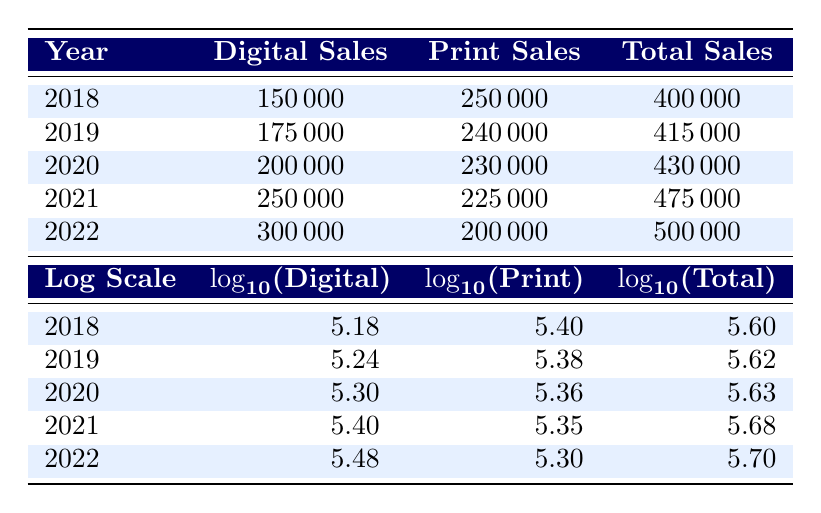What were the Digital Book Sales in 2021? The table shows that the Digital Book Sales in 2021 were 250,000.
Answer: 250,000 What was the total number of Print Book Sales in 2019? According to the table, the Print Book Sales in 2019 were 240,000.
Answer: 240,000 What is the difference between Total Book Sales in 2022 and 2021? In 2022 the Total Book Sales were 500,000 and in 2021 they were 475,000. The difference is calculated as 500,000 - 475,000 = 25,000.
Answer: 25,000 Was Digital Book Sales higher than Print Book Sales in any year during the specified period? Yes, from the table, in 2022, Digital Book Sales (300,000) were higher than Print Book Sales (200,000).
Answer: Yes What was the average Digital Book Sales over the five years? The Digital Book Sales over five years are 150,000, 175,000, 200,000, 250,000, and 300,000. Summing these gives 1,075,000. Dividing by 5 gives an average of 1,075,000 / 5 = 215,000.
Answer: 215,000 In which year did Total Book Sales first exceed 450,000? The table shows that Total Book Sales exceeded 450,000 in 2021 (475,000) for the first time, as 430,000 in 2020 is below that threshold.
Answer: 2021 What was the highest value of Print Book Sales in these years? The table indicates that the highest value of Print Book Sales occurred in 2018, with 250,000.
Answer: 250,000 Was there an overall increase in Total Book Sales each year from 2018 to 2022? No, by examining the Total Book Sales, we see that they increased every year except for a decrease from 240,000 in 2019 to 230,000 in 2020, thus confirming that not every year had an increase.
Answer: No 